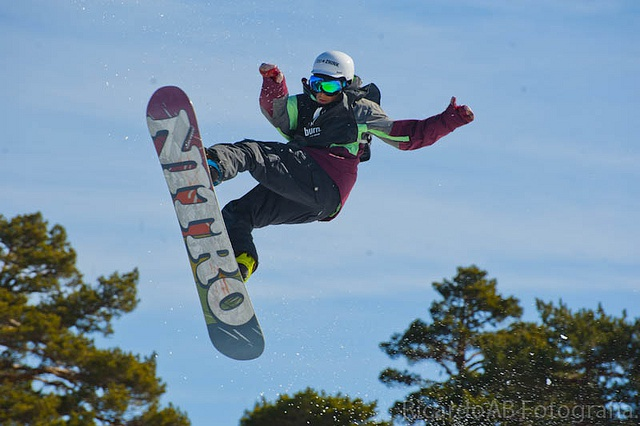Describe the objects in this image and their specific colors. I can see people in darkgray, black, gray, and purple tones and snowboard in darkgray, gray, blue, and purple tones in this image. 